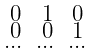<formula> <loc_0><loc_0><loc_500><loc_500>\begin{smallmatrix} 0 & 1 & 0 \\ 0 & 0 & 1 \\ \dots & \dots & \dots \end{smallmatrix}</formula> 